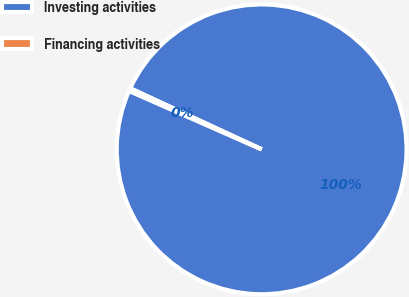<chart> <loc_0><loc_0><loc_500><loc_500><pie_chart><fcel>Investing activities<fcel>Financing activities<nl><fcel>99.69%<fcel>0.31%<nl></chart> 